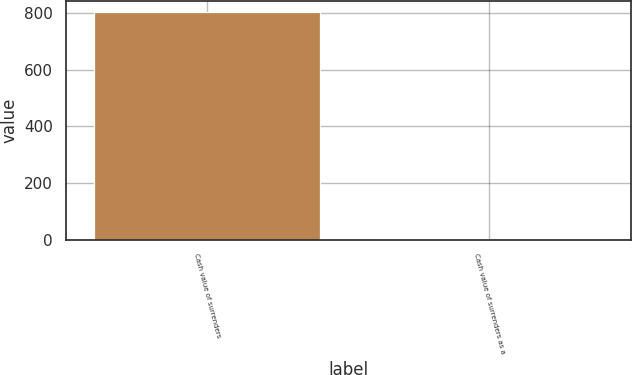Convert chart. <chart><loc_0><loc_0><loc_500><loc_500><bar_chart><fcel>Cash value of surrenders<fcel>Cash value of surrenders as a<nl><fcel>802<fcel>3.8<nl></chart> 